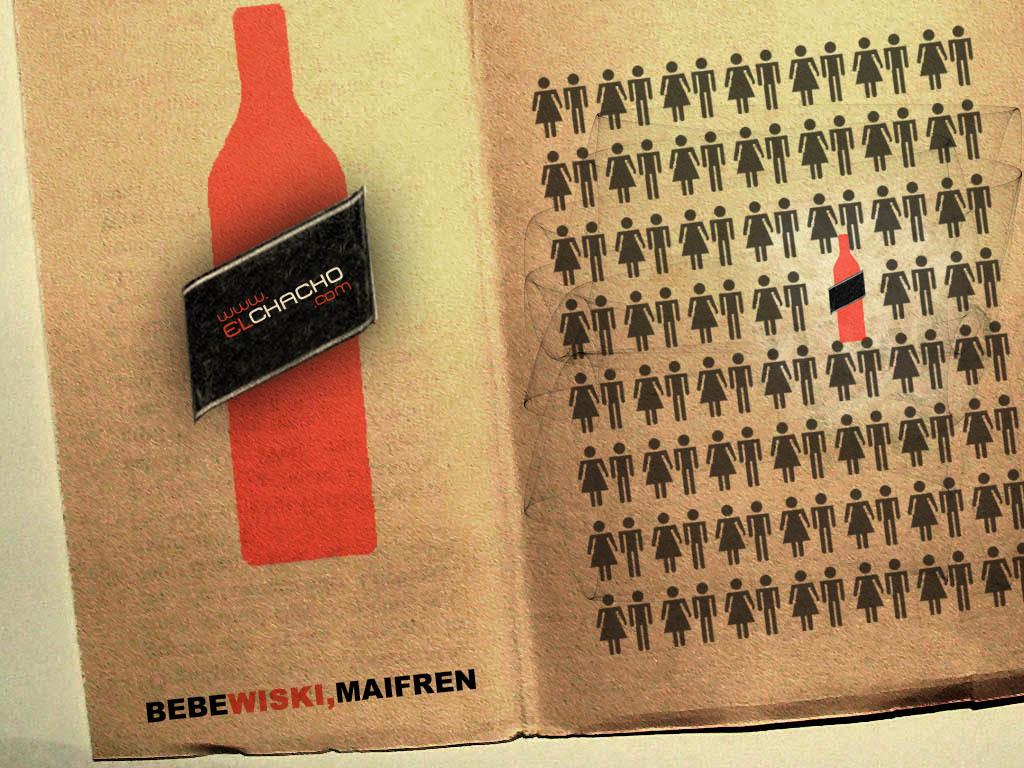<image>
Give a short and clear explanation of the subsequent image. An advertisement for ww.elchacho.com, Bebewiski, Maifren has a sketch of a red bottle and men and women figures. 